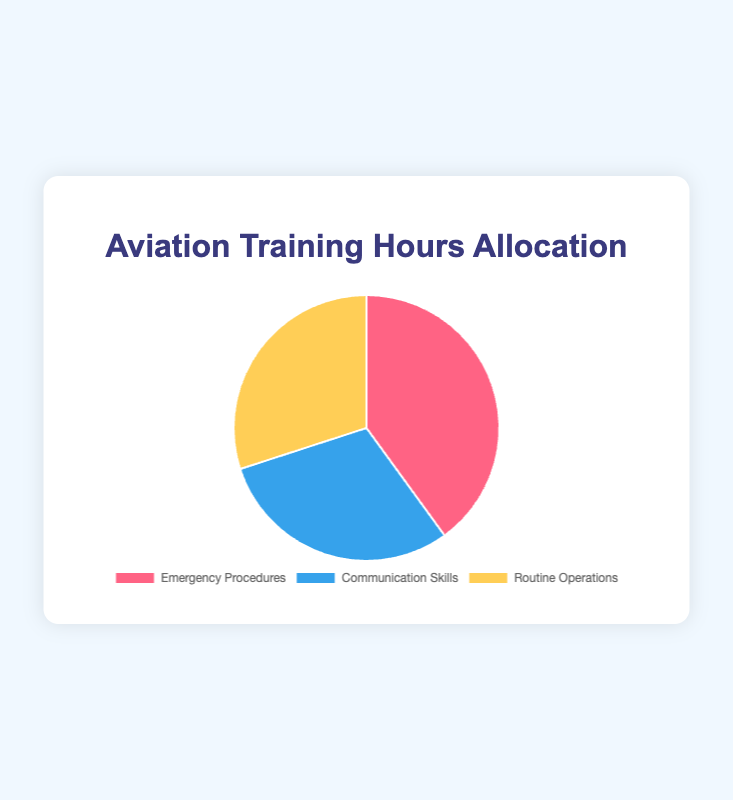What is the total number of training hours? Summing all the allocation hours: Emergency Procedures (40 hours) + Communication Skills (30 hours) + Routine Operations (30 hours) gives a total of 100 hours
Answer: 100 Which category has the highest allocation of training hours? From the pie chart, Emergency Procedures has a larger portion compared to the other categories, with 40 hours
Answer: Emergency Procedures How many more hours are allocated to Emergency Procedures than to Routine Operations? Emergency Procedures has 40 hours, and Routine Operations has 30 hours. The difference is 40 - 30 which equals 10 hours
Answer: 10 What fraction of the training hours is dedicated to Communication Skills? Total training hours are 100. Communication Skills has 30 hours. The fraction is 30/100 which simplifies to 3/10 or 0.3
Answer: 3/10 Which two categories have equal training hours allocated? Both Communication Skills and Routine Operations have 30 hours allocated based on the pie chart
Answer: Communication Skills and Routine Operations What percentage of the training hours is allocated to Emergency Procedures? Emergency Procedures has 40 out of 100 hours. The percentage is (40/100) * 100% which equals 40%
Answer: 40% How much more time is spent on Emergency Procedures compared to the average time spent on Communication Skills and Routine Operations combined? Average time for Communication Skills and Routine Operations is (30 + 30)/2 = 30 hours. Emergency Procedures has 40 hours. The difference is 40 - 30 which equals 10 hours
Answer: 10 What are the colors associated with each category in the pie chart? Emergency Procedures is associated with red, Communication Skills is associated with blue, and Routine Operations is associated with yellow
Answer: red, blue, yellow What is the sum of the hours allocated to Communication Skills and Routine Operations? The sum of Communication Skills and Routine Operations is 30 + 30 which equals 60 hours
Answer: 60 